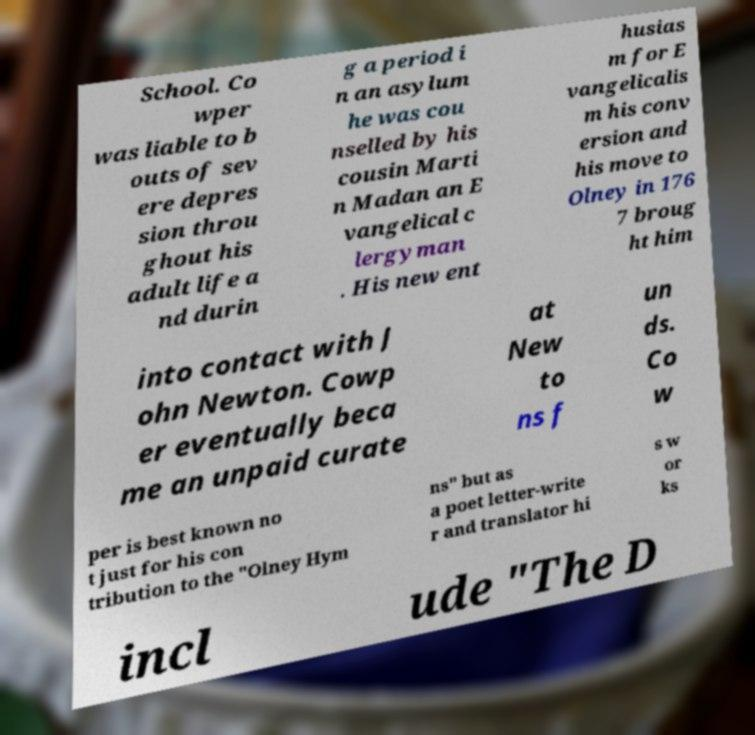I need the written content from this picture converted into text. Can you do that? School. Co wper was liable to b outs of sev ere depres sion throu ghout his adult life a nd durin g a period i n an asylum he was cou nselled by his cousin Marti n Madan an E vangelical c lergyman . His new ent husias m for E vangelicalis m his conv ersion and his move to Olney in 176 7 broug ht him into contact with J ohn Newton. Cowp er eventually beca me an unpaid curate at New to ns f un ds. Co w per is best known no t just for his con tribution to the "Olney Hym ns" but as a poet letter-write r and translator hi s w or ks incl ude "The D 